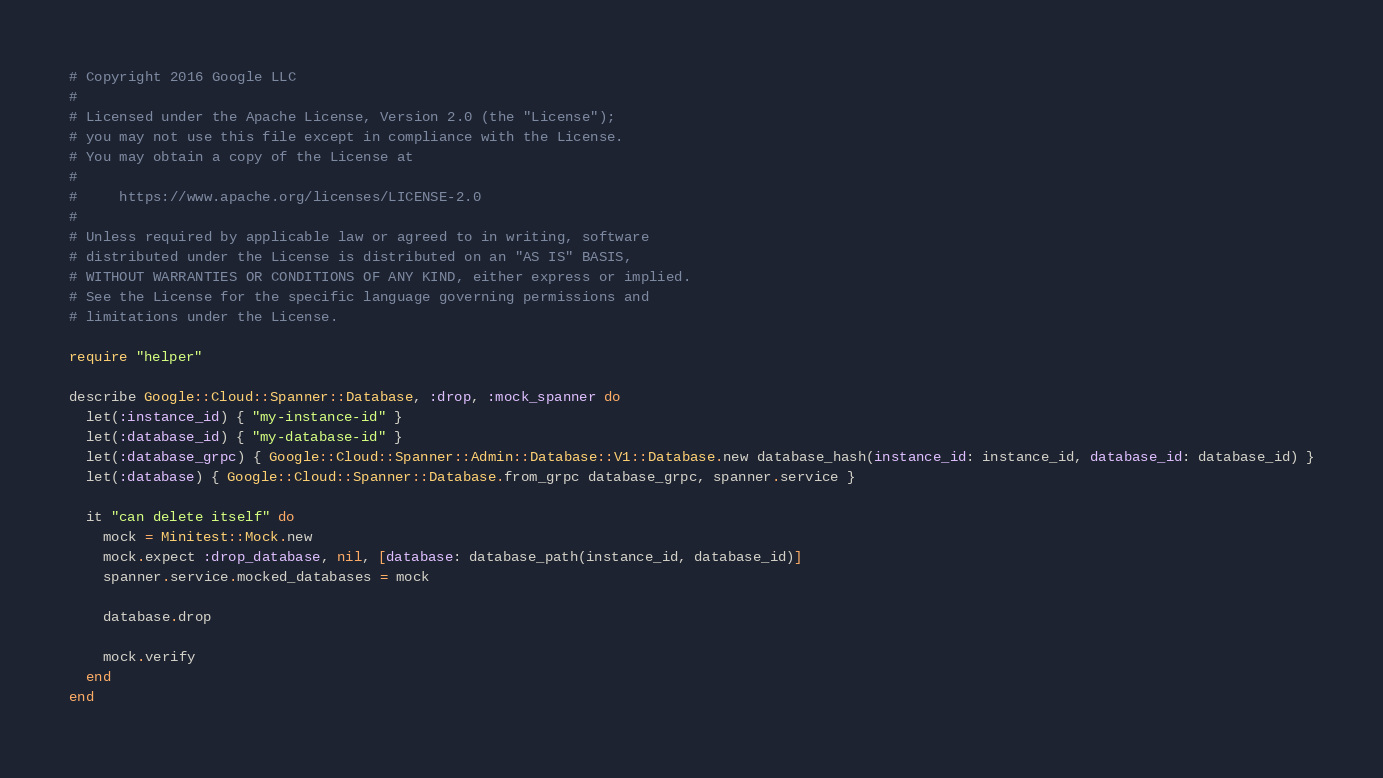<code> <loc_0><loc_0><loc_500><loc_500><_Ruby_># Copyright 2016 Google LLC
#
# Licensed under the Apache License, Version 2.0 (the "License");
# you may not use this file except in compliance with the License.
# You may obtain a copy of the License at
#
#     https://www.apache.org/licenses/LICENSE-2.0
#
# Unless required by applicable law or agreed to in writing, software
# distributed under the License is distributed on an "AS IS" BASIS,
# WITHOUT WARRANTIES OR CONDITIONS OF ANY KIND, either express or implied.
# See the License for the specific language governing permissions and
# limitations under the License.

require "helper"

describe Google::Cloud::Spanner::Database, :drop, :mock_spanner do
  let(:instance_id) { "my-instance-id" }
  let(:database_id) { "my-database-id" }
  let(:database_grpc) { Google::Cloud::Spanner::Admin::Database::V1::Database.new database_hash(instance_id: instance_id, database_id: database_id) }
  let(:database) { Google::Cloud::Spanner::Database.from_grpc database_grpc, spanner.service }

  it "can delete itself" do
    mock = Minitest::Mock.new
    mock.expect :drop_database, nil, [database: database_path(instance_id, database_id)]
    spanner.service.mocked_databases = mock

    database.drop

    mock.verify
  end
end
</code> 